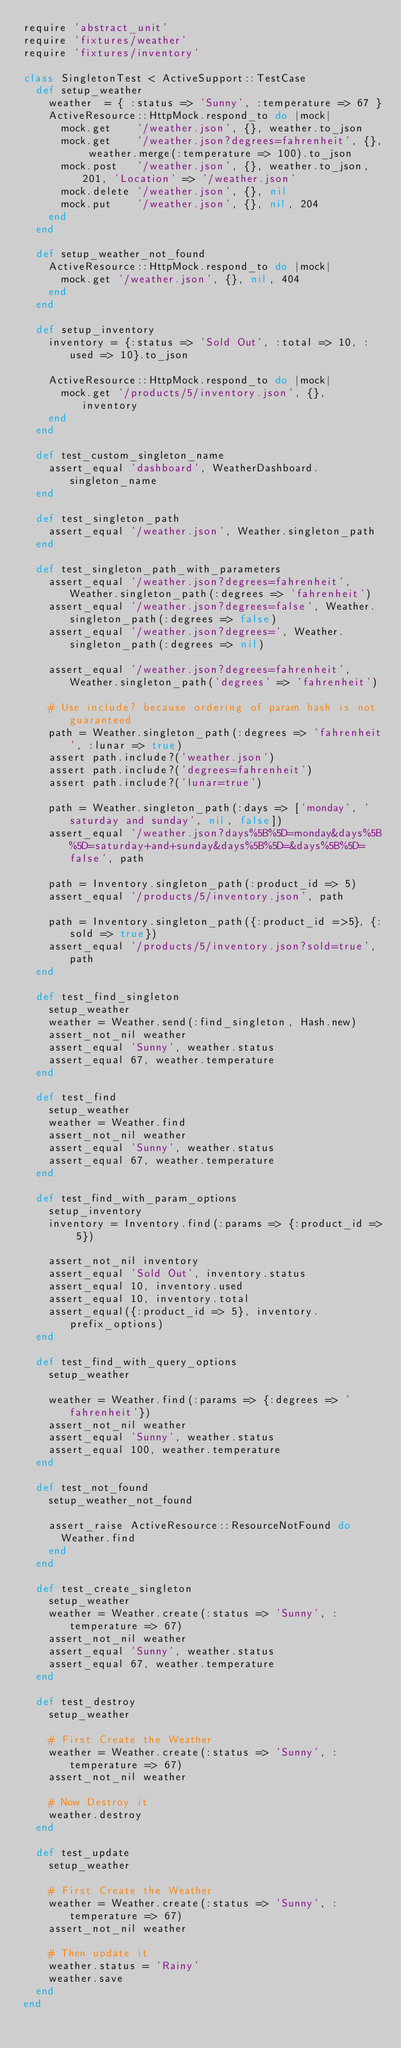Convert code to text. <code><loc_0><loc_0><loc_500><loc_500><_Ruby_>require 'abstract_unit'
require 'fixtures/weather'
require 'fixtures/inventory'

class SingletonTest < ActiveSupport::TestCase
  def setup_weather
    weather  = { :status => 'Sunny', :temperature => 67 }
    ActiveResource::HttpMock.respond_to do |mock|
      mock.get    '/weather.json', {}, weather.to_json
      mock.get    '/weather.json?degrees=fahrenheit', {}, weather.merge(:temperature => 100).to_json
      mock.post   '/weather.json', {}, weather.to_json, 201, 'Location' => '/weather.json'
      mock.delete '/weather.json', {}, nil
      mock.put    '/weather.json', {}, nil, 204
    end
  end

  def setup_weather_not_found
    ActiveResource::HttpMock.respond_to do |mock|
      mock.get '/weather.json', {}, nil, 404
    end
  end

  def setup_inventory
    inventory = {:status => 'Sold Out', :total => 10, :used => 10}.to_json

    ActiveResource::HttpMock.respond_to do |mock|
      mock.get '/products/5/inventory.json', {}, inventory
    end
  end

  def test_custom_singleton_name
    assert_equal 'dashboard', WeatherDashboard.singleton_name
  end

  def test_singleton_path
    assert_equal '/weather.json', Weather.singleton_path
  end

  def test_singleton_path_with_parameters
    assert_equal '/weather.json?degrees=fahrenheit', Weather.singleton_path(:degrees => 'fahrenheit')
    assert_equal '/weather.json?degrees=false', Weather.singleton_path(:degrees => false)
    assert_equal '/weather.json?degrees=', Weather.singleton_path(:degrees => nil)

    assert_equal '/weather.json?degrees=fahrenheit', Weather.singleton_path('degrees' => 'fahrenheit')

    # Use include? because ordering of param hash is not guaranteed
    path = Weather.singleton_path(:degrees => 'fahrenheit', :lunar => true)
    assert path.include?('weather.json')
    assert path.include?('degrees=fahrenheit')
    assert path.include?('lunar=true')

    path = Weather.singleton_path(:days => ['monday', 'saturday and sunday', nil, false])
    assert_equal '/weather.json?days%5B%5D=monday&days%5B%5D=saturday+and+sunday&days%5B%5D=&days%5B%5D=false', path

    path = Inventory.singleton_path(:product_id => 5)
    assert_equal '/products/5/inventory.json', path

    path = Inventory.singleton_path({:product_id =>5}, {:sold => true})
    assert_equal '/products/5/inventory.json?sold=true', path
  end

  def test_find_singleton
    setup_weather
    weather = Weather.send(:find_singleton, Hash.new)
    assert_not_nil weather
    assert_equal 'Sunny', weather.status
    assert_equal 67, weather.temperature
  end

  def test_find
    setup_weather
    weather = Weather.find
    assert_not_nil weather
    assert_equal 'Sunny', weather.status
    assert_equal 67, weather.temperature
  end

  def test_find_with_param_options
    setup_inventory
    inventory = Inventory.find(:params => {:product_id => 5})

    assert_not_nil inventory
    assert_equal 'Sold Out', inventory.status
    assert_equal 10, inventory.used
    assert_equal 10, inventory.total
    assert_equal({:product_id => 5}, inventory.prefix_options)
  end

  def test_find_with_query_options
    setup_weather

    weather = Weather.find(:params => {:degrees => 'fahrenheit'})
    assert_not_nil weather
    assert_equal 'Sunny', weather.status
    assert_equal 100, weather.temperature
  end

  def test_not_found
    setup_weather_not_found

    assert_raise ActiveResource::ResourceNotFound do
      Weather.find
    end
  end

  def test_create_singleton
    setup_weather
    weather = Weather.create(:status => 'Sunny', :temperature => 67)
    assert_not_nil weather
    assert_equal 'Sunny', weather.status
    assert_equal 67, weather.temperature
  end

  def test_destroy
    setup_weather

    # First Create the Weather
    weather = Weather.create(:status => 'Sunny', :temperature => 67)
    assert_not_nil weather

    # Now Destroy it
    weather.destroy
  end

  def test_update
    setup_weather

    # First Create the Weather
    weather = Weather.create(:status => 'Sunny', :temperature => 67)
    assert_not_nil weather

    # Then update it
    weather.status = 'Rainy'
    weather.save
  end
end

</code> 